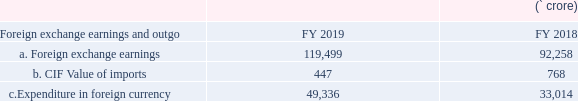Foreign exchange earnings and outgo
Export revenue constituted 93.3 percent of the total unconsolidated revenue in FY 2019 (92.2 percent in FY 2018).
What information does the table show? Foreign exchange earnings and outgo. What portion of total unconsolidated revenue in FY 2019 constitutes of export revenue?
Answer scale should be: percent. 93.3. What portion of total unconsolidated revenue in FY 2018 constitutes of export revenue?
Answer scale should be: percent. 92.2. What is the change in foreign exchange earnings from FY 2018 to FY 2019? 119,499-92,258 
Answer: 27241. What is the change in Cost, Insurance and Freight (CIF) value of imports from FY 2018 to FY 2019? 768-447 
Answer: 321. What is the ratio of foreign exchange earnings to expenditure in foreign currency in FY 2019? 119,499/49,336 
Answer: 2.42. 